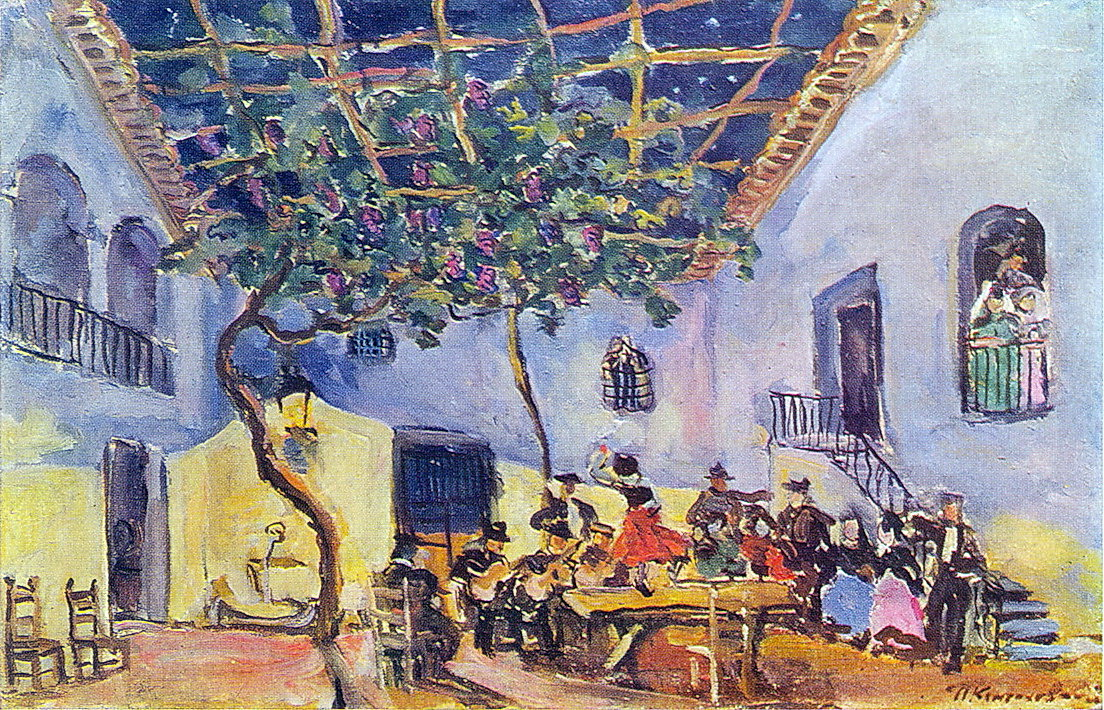What's happening in the scene? The image depicts a lively and colorful courtyard scene, painted with an impressionist style known for its loose, fluid brushstrokes and bright, bold colors. The artist, Henri Matisse, captures the vibrancy of a social gathering under a clear blue sky. The courtyard is filled with lush greenery and the central focus is a group of people engaged in conversation. They are dressed in colorful clothing which adds to the overall sense of movement and energy. The impressionist approach allows for a level of abstraction, leaving the finer details to the viewer's imagination. Overall, it's a beautiful representation of a joyous social gathering in an outdoor setting, bursting with colors and life. 